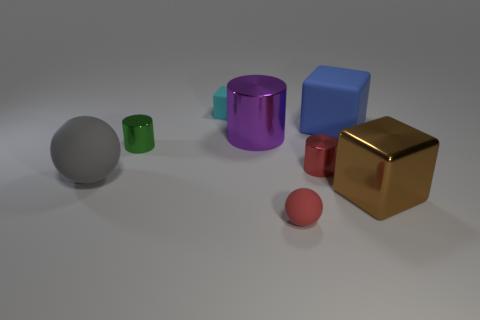The tiny block has what color?
Ensure brevity in your answer.  Cyan. Is the number of small green shiny things that are to the right of the gray object greater than the number of big gray matte things behind the blue matte thing?
Offer a very short reply. Yes. There is a rubber block on the right side of the big cylinder; what is its color?
Ensure brevity in your answer.  Blue. There is a shiny object that is left of the cyan rubber block; is its size the same as the block that is in front of the tiny green metallic cylinder?
Offer a very short reply. No. What number of things are either small rubber objects or tiny balls?
Ensure brevity in your answer.  2. The large cube that is on the left side of the block that is in front of the big blue rubber block is made of what material?
Keep it short and to the point. Rubber. How many other objects are the same shape as the big gray object?
Your response must be concise. 1. Are there any metallic objects that have the same color as the small block?
Your response must be concise. No. How many objects are things in front of the green thing or small objects in front of the large gray matte object?
Ensure brevity in your answer.  4. Are there any large blue blocks that are in front of the sphere on the right side of the big purple object?
Make the answer very short. No. 